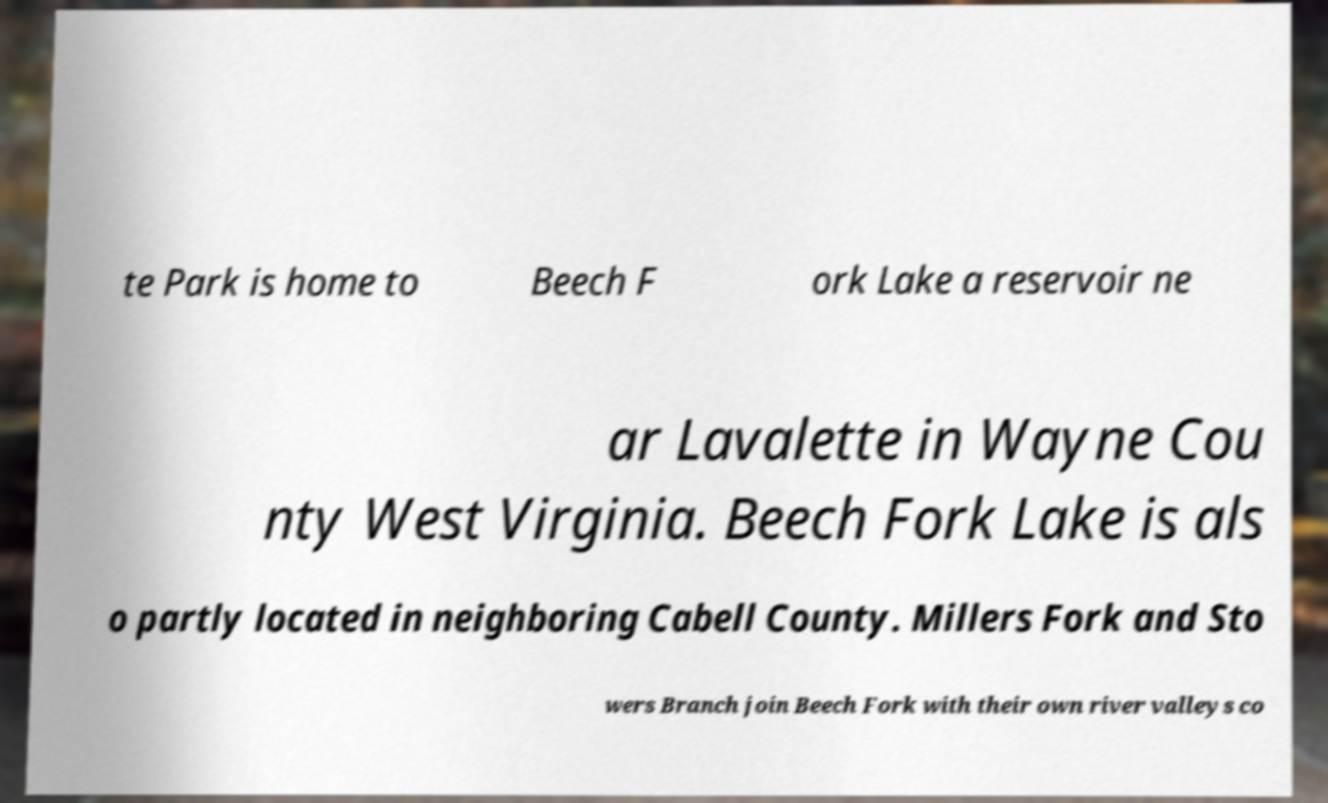I need the written content from this picture converted into text. Can you do that? te Park is home to Beech F ork Lake a reservoir ne ar Lavalette in Wayne Cou nty West Virginia. Beech Fork Lake is als o partly located in neighboring Cabell County. Millers Fork and Sto wers Branch join Beech Fork with their own river valleys co 